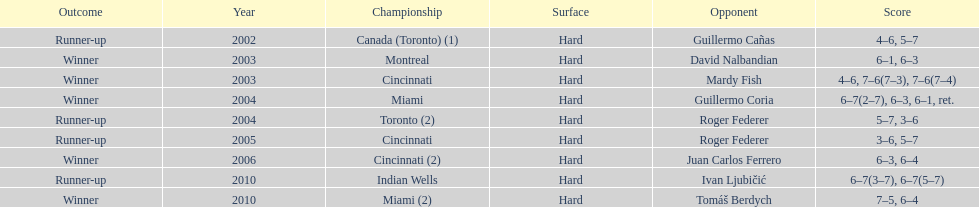How many times has he been runner-up? 4. 